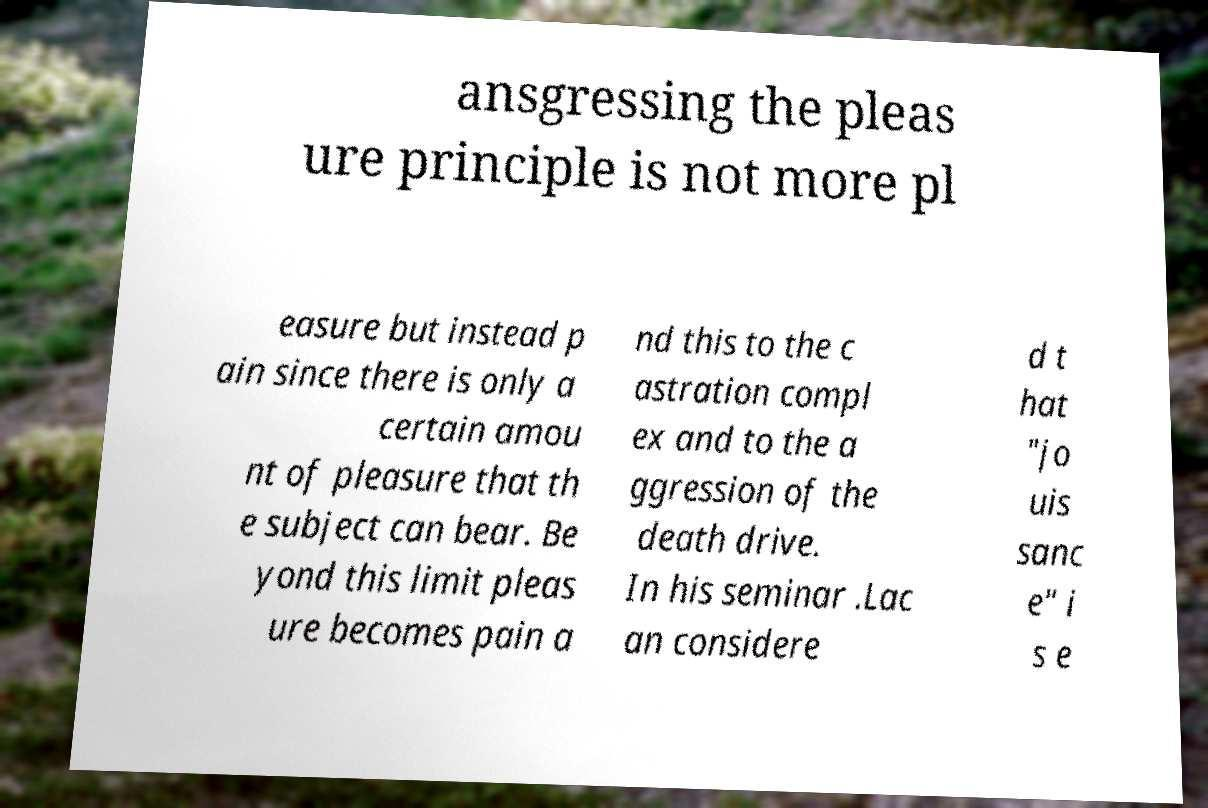For documentation purposes, I need the text within this image transcribed. Could you provide that? ansgressing the pleas ure principle is not more pl easure but instead p ain since there is only a certain amou nt of pleasure that th e subject can bear. Be yond this limit pleas ure becomes pain a nd this to the c astration compl ex and to the a ggression of the death drive. In his seminar .Lac an considere d t hat "jo uis sanc e" i s e 